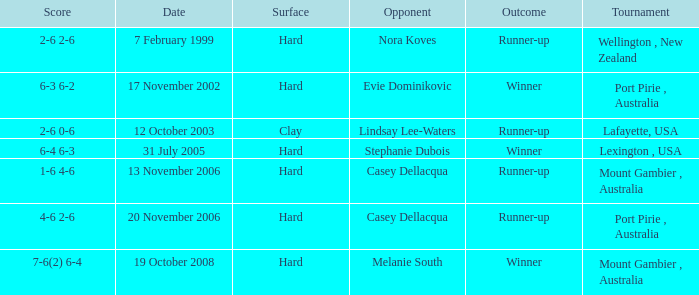Which Outcome has a Opponent of lindsay lee-waters? Runner-up. 